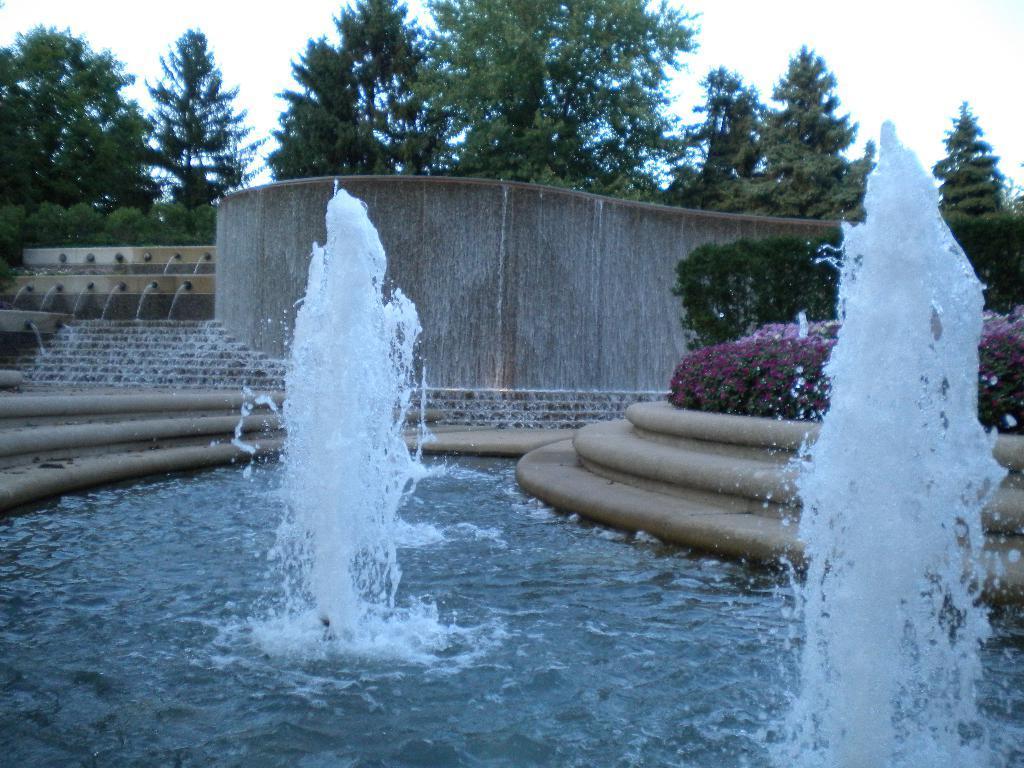In one or two sentences, can you explain what this image depicts? At the bottom of the image there is water with a fountains. Behind the fountains at the right side there are steps with a plants and violet flowers. In the background there are few steps with water flowing and also there is a wall with water flowing. Behind the wall there are trees and also in the background there is a sky. 